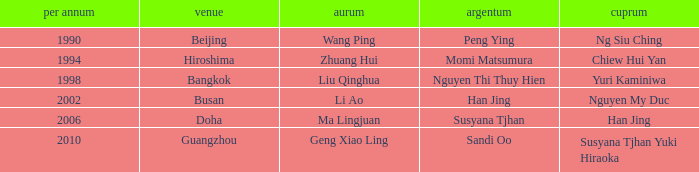What's the lowest Year with the Location of Bangkok? 1998.0. 